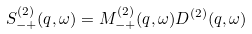Convert formula to latex. <formula><loc_0><loc_0><loc_500><loc_500>S _ { - + } ^ { ( 2 ) } ( q , \omega ) = M _ { - + } ^ { ( 2 ) } ( q , \omega ) D ^ { ( 2 ) } ( q , \omega )</formula> 